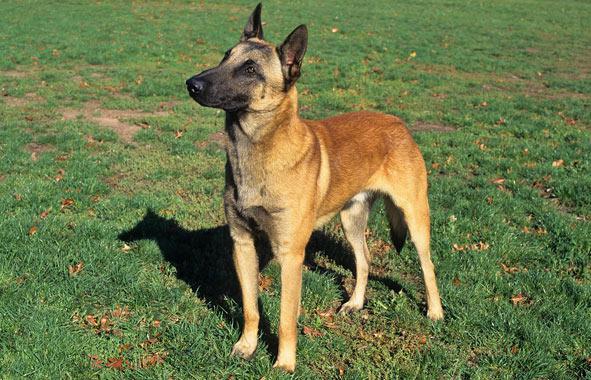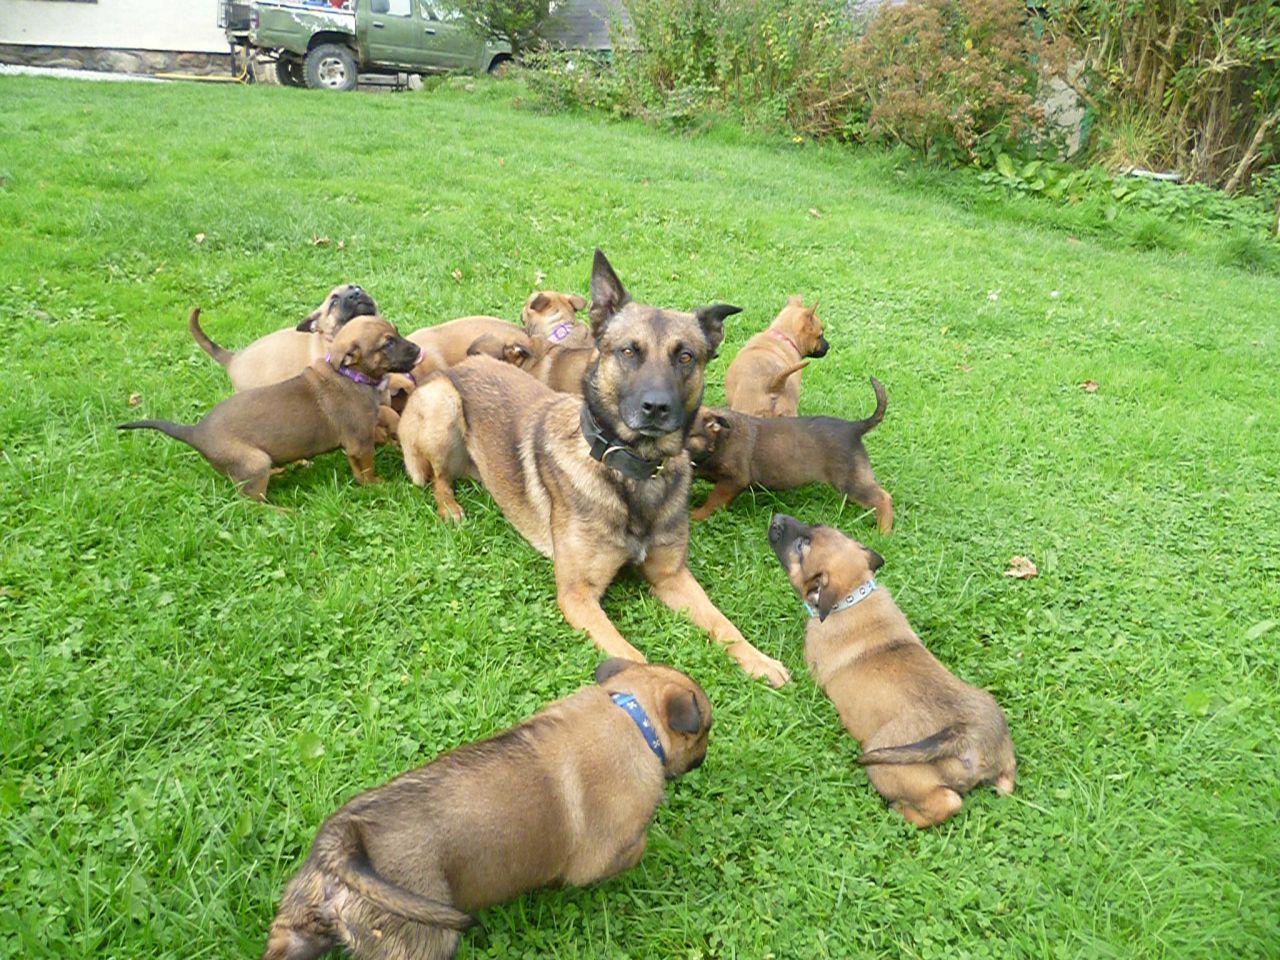The first image is the image on the left, the second image is the image on the right. For the images shown, is this caption "Three german shepherd dogs sit upright in a row on grass in one image." true? Answer yes or no. No. The first image is the image on the left, the second image is the image on the right. Considering the images on both sides, is "The right image contains exactly three dogs." valid? Answer yes or no. No. 